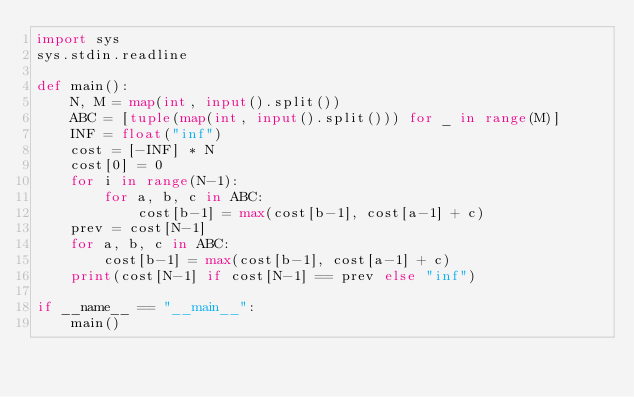<code> <loc_0><loc_0><loc_500><loc_500><_Python_>import sys
sys.stdin.readline

def main():
    N, M = map(int, input().split())
    ABC = [tuple(map(int, input().split())) for _ in range(M)]
    INF = float("inf")
    cost = [-INF] * N
    cost[0] = 0
    for i in range(N-1):
        for a, b, c in ABC:
            cost[b-1] = max(cost[b-1], cost[a-1] + c)
    prev = cost[N-1]
    for a, b, c in ABC:
        cost[b-1] = max(cost[b-1], cost[a-1] + c)    
    print(cost[N-1] if cost[N-1] == prev else "inf")

if __name__ == "__main__":
    main()</code> 